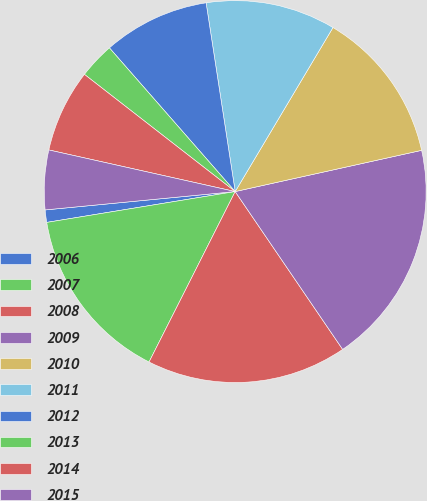<chart> <loc_0><loc_0><loc_500><loc_500><pie_chart><fcel>2006<fcel>2007<fcel>2008<fcel>2009<fcel>2010<fcel>2011<fcel>2012<fcel>2013<fcel>2014<fcel>2015<nl><fcel>1.05%<fcel>14.97%<fcel>16.96%<fcel>18.95%<fcel>12.98%<fcel>10.99%<fcel>9.01%<fcel>3.04%<fcel>7.02%<fcel>5.03%<nl></chart> 